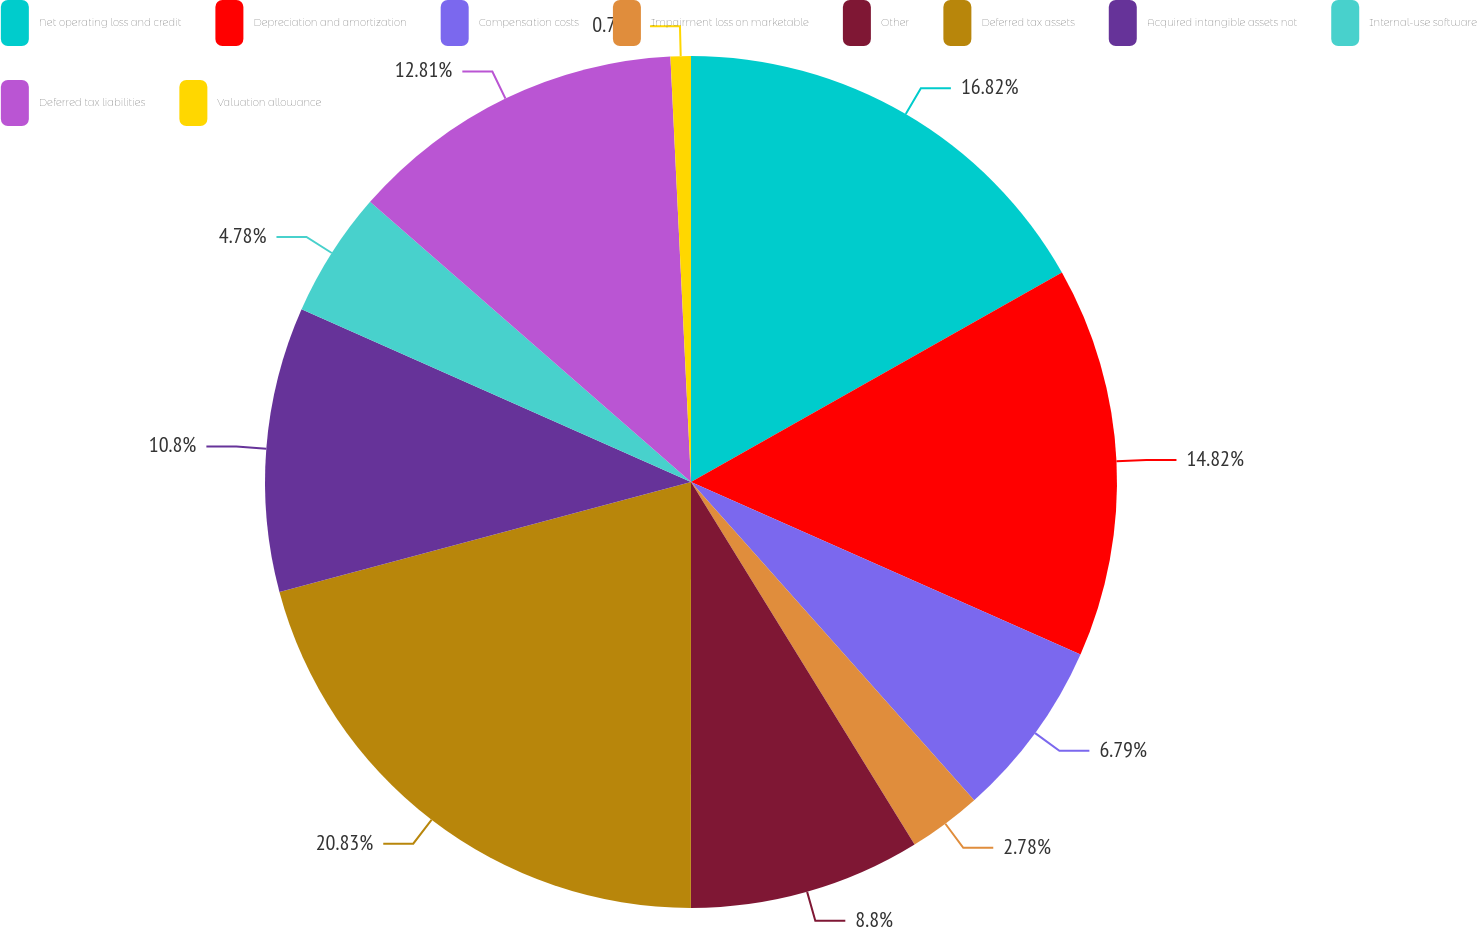Convert chart to OTSL. <chart><loc_0><loc_0><loc_500><loc_500><pie_chart><fcel>Net operating loss and credit<fcel>Depreciation and amortization<fcel>Compensation costs<fcel>Impairment loss on marketable<fcel>Other<fcel>Deferred tax assets<fcel>Acquired intangible assets not<fcel>Internal-use software<fcel>Deferred tax liabilities<fcel>Valuation allowance<nl><fcel>16.82%<fcel>14.82%<fcel>6.79%<fcel>2.78%<fcel>8.8%<fcel>20.84%<fcel>10.8%<fcel>4.78%<fcel>12.81%<fcel>0.77%<nl></chart> 